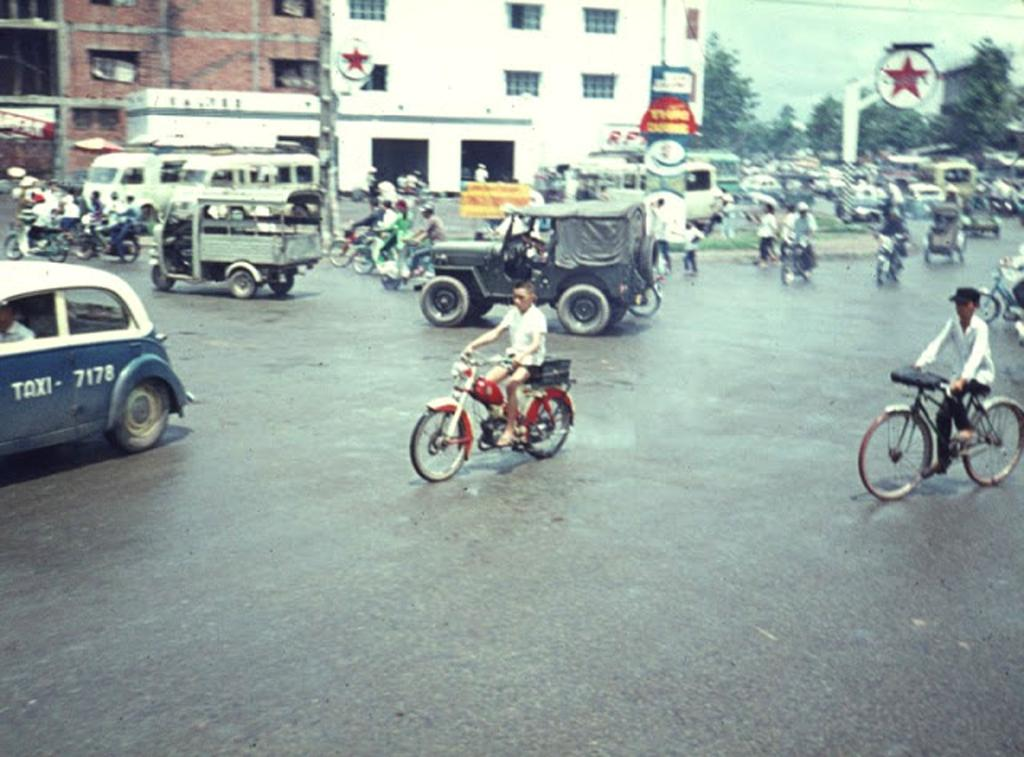What is the man doing in the middle of the image? There is a man riding a vehicle in the middle of the image. What else can be seen on the left side of the image? A car is moving on the road on the left side of the image. What is visible in the background of the image? There are buildings visible at the back side of the image. What type of vegetation is on the right side of the image? There are trees on the right side of the image. What type of twig is the man holding while riding the vehicle in the image? There is no twig present in the image; the man is riding a vehicle. How much sugar is being used by the car on the left side of the image? There is no sugar mentioned or visible in the image; it features a car moving on the road. 